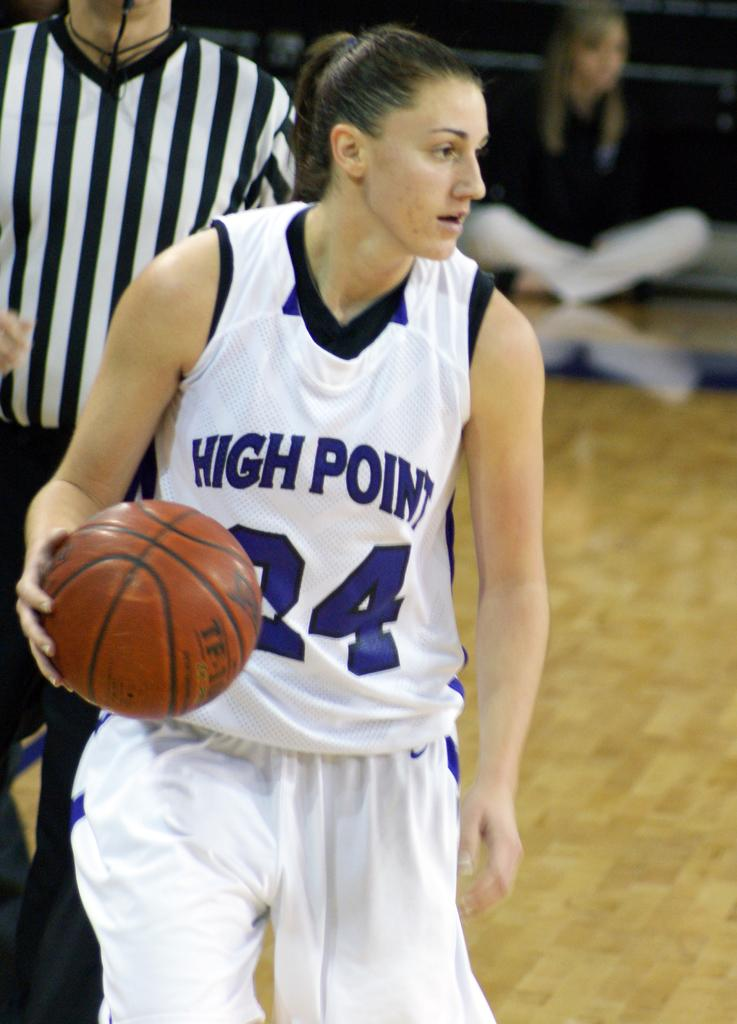<image>
Give a short and clear explanation of the subsequent image. A female basketball player wearing a jersey depicting the number 24 holds a basketball. 